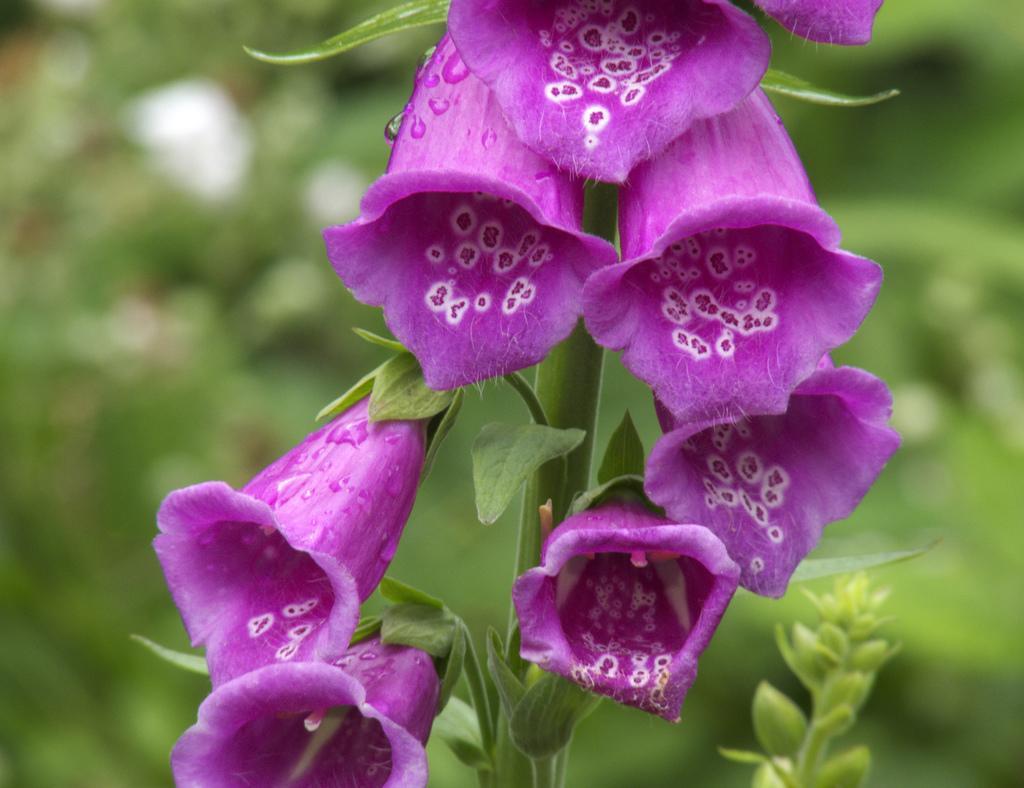In one or two sentences, can you explain what this image depicts? This looks like a plant with the flowers, which are violet in color. These are the leaves. The background looks blurry. 